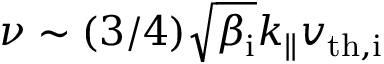<formula> <loc_0><loc_0><loc_500><loc_500>\nu \sim ( 3 / 4 ) \sqrt { \beta _ { i } } k _ { \| } v _ { t h , i }</formula> 